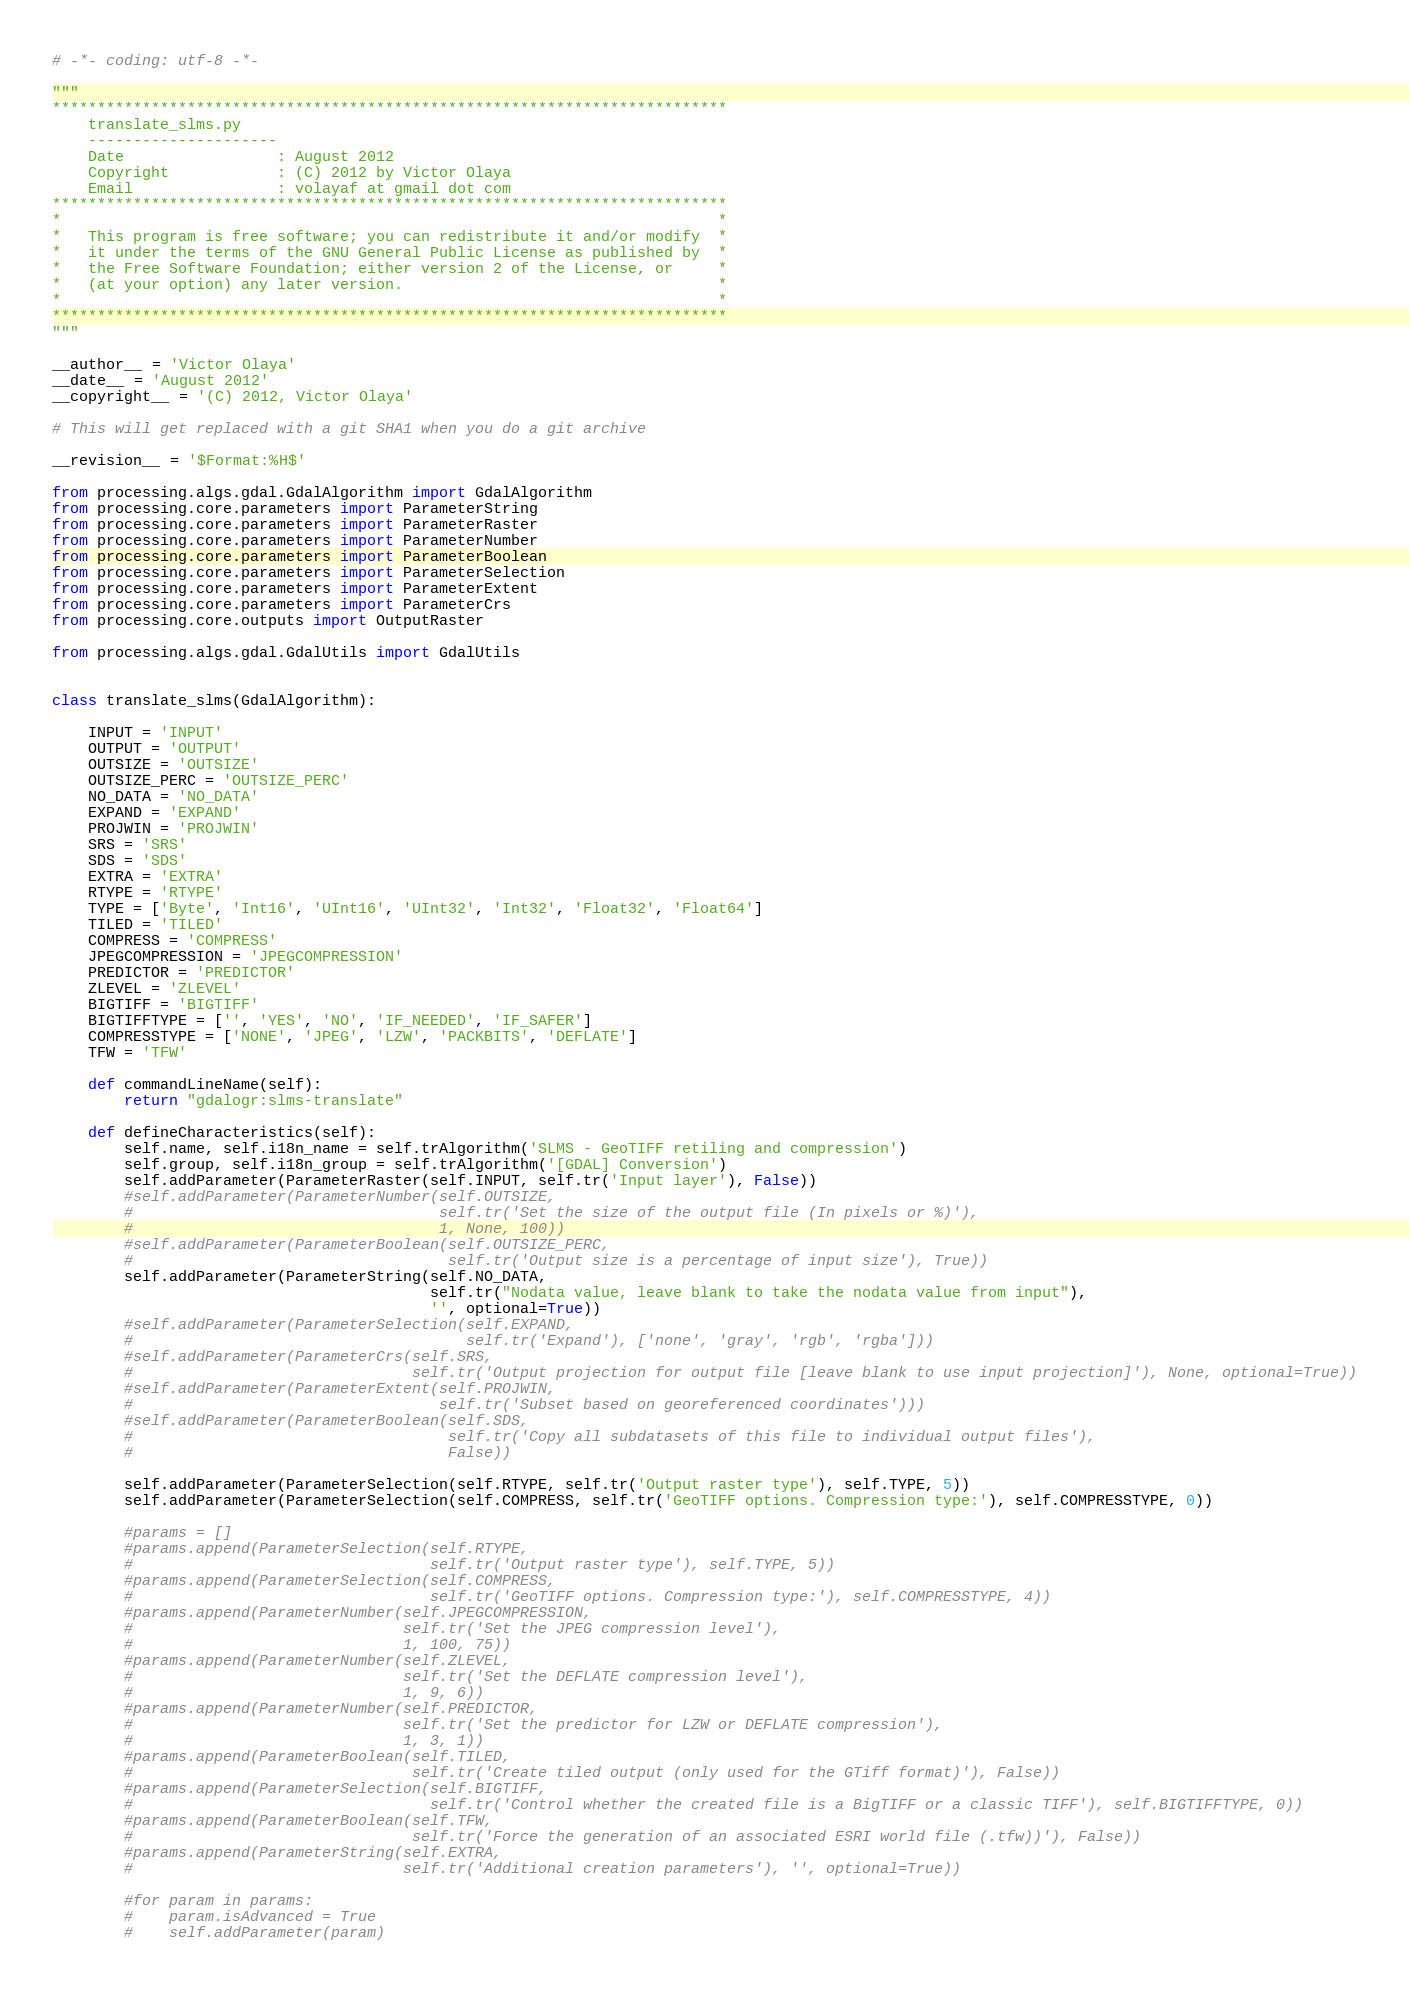Convert code to text. <code><loc_0><loc_0><loc_500><loc_500><_Python_># -*- coding: utf-8 -*-

"""
***************************************************************************
    translate_slms.py
    ---------------------
    Date                 : August 2012
    Copyright            : (C) 2012 by Victor Olaya
    Email                : volayaf at gmail dot com
***************************************************************************
*                                                                         *
*   This program is free software; you can redistribute it and/or modify  *
*   it under the terms of the GNU General Public License as published by  *
*   the Free Software Foundation; either version 2 of the License, or     *
*   (at your option) any later version.                                   *
*                                                                         *
***************************************************************************
"""

__author__ = 'Victor Olaya'
__date__ = 'August 2012'
__copyright__ = '(C) 2012, Victor Olaya'

# This will get replaced with a git SHA1 when you do a git archive

__revision__ = '$Format:%H$'

from processing.algs.gdal.GdalAlgorithm import GdalAlgorithm
from processing.core.parameters import ParameterString
from processing.core.parameters import ParameterRaster
from processing.core.parameters import ParameterNumber
from processing.core.parameters import ParameterBoolean
from processing.core.parameters import ParameterSelection
from processing.core.parameters import ParameterExtent
from processing.core.parameters import ParameterCrs
from processing.core.outputs import OutputRaster

from processing.algs.gdal.GdalUtils import GdalUtils


class translate_slms(GdalAlgorithm):

    INPUT = 'INPUT'
    OUTPUT = 'OUTPUT'
    OUTSIZE = 'OUTSIZE'
    OUTSIZE_PERC = 'OUTSIZE_PERC'
    NO_DATA = 'NO_DATA'
    EXPAND = 'EXPAND'
    PROJWIN = 'PROJWIN'
    SRS = 'SRS'
    SDS = 'SDS'
    EXTRA = 'EXTRA'
    RTYPE = 'RTYPE'
    TYPE = ['Byte', 'Int16', 'UInt16', 'UInt32', 'Int32', 'Float32', 'Float64']
    TILED = 'TILED'
    COMPRESS = 'COMPRESS'
    JPEGCOMPRESSION = 'JPEGCOMPRESSION'
    PREDICTOR = 'PREDICTOR'
    ZLEVEL = 'ZLEVEL'
    BIGTIFF = 'BIGTIFF'
    BIGTIFFTYPE = ['', 'YES', 'NO', 'IF_NEEDED', 'IF_SAFER']
    COMPRESSTYPE = ['NONE', 'JPEG', 'LZW', 'PACKBITS', 'DEFLATE']
    TFW = 'TFW'

    def commandLineName(self):
        return "gdalogr:slms-translate"

    def defineCharacteristics(self):
        self.name, self.i18n_name = self.trAlgorithm('SLMS - GeoTIFF retiling and compression')
        self.group, self.i18n_group = self.trAlgorithm('[GDAL] Conversion')
        self.addParameter(ParameterRaster(self.INPUT, self.tr('Input layer'), False))
        #self.addParameter(ParameterNumber(self.OUTSIZE,
        #                                  self.tr('Set the size of the output file (In pixels or %)'),
        #                                  1, None, 100))
        #self.addParameter(ParameterBoolean(self.OUTSIZE_PERC,
        #                                   self.tr('Output size is a percentage of input size'), True))
        self.addParameter(ParameterString(self.NO_DATA,
                                          self.tr("Nodata value, leave blank to take the nodata value from input"),
                                          '', optional=True))
        #self.addParameter(ParameterSelection(self.EXPAND,
        #                                     self.tr('Expand'), ['none', 'gray', 'rgb', 'rgba']))
        #self.addParameter(ParameterCrs(self.SRS,
        #                               self.tr('Output projection for output file [leave blank to use input projection]'), None, optional=True))
        #self.addParameter(ParameterExtent(self.PROJWIN,
        #                                  self.tr('Subset based on georeferenced coordinates')))
        #self.addParameter(ParameterBoolean(self.SDS,
        #                                   self.tr('Copy all subdatasets of this file to individual output files'),
        #                                   False))
        
        self.addParameter(ParameterSelection(self.RTYPE, self.tr('Output raster type'), self.TYPE, 5))
        self.addParameter(ParameterSelection(self.COMPRESS, self.tr('GeoTIFF options. Compression type:'), self.COMPRESSTYPE, 0))
        
		#params = []
        #params.append(ParameterSelection(self.RTYPE,
        #                                 self.tr('Output raster type'), self.TYPE, 5))
        #params.append(ParameterSelection(self.COMPRESS,
        #                                 self.tr('GeoTIFF options. Compression type:'), self.COMPRESSTYPE, 4))
        #params.append(ParameterNumber(self.JPEGCOMPRESSION,
        #                              self.tr('Set the JPEG compression level'),
        #                              1, 100, 75))
        #params.append(ParameterNumber(self.ZLEVEL,
        #                              self.tr('Set the DEFLATE compression level'),
        #                              1, 9, 6))
        #params.append(ParameterNumber(self.PREDICTOR,
        #                              self.tr('Set the predictor for LZW or DEFLATE compression'),
        #                              1, 3, 1))
        #params.append(ParameterBoolean(self.TILED,
        #                               self.tr('Create tiled output (only used for the GTiff format)'), False))
        #params.append(ParameterSelection(self.BIGTIFF,
        #                                 self.tr('Control whether the created file is a BigTIFF or a classic TIFF'), self.BIGTIFFTYPE, 0))
        #params.append(ParameterBoolean(self.TFW,
        #                               self.tr('Force the generation of an associated ESRI world file (.tfw))'), False))
        #params.append(ParameterString(self.EXTRA,
        #                              self.tr('Additional creation parameters'), '', optional=True))

        #for param in params:
        #    param.isAdvanced = True
        #    self.addParameter(param)
</code> 